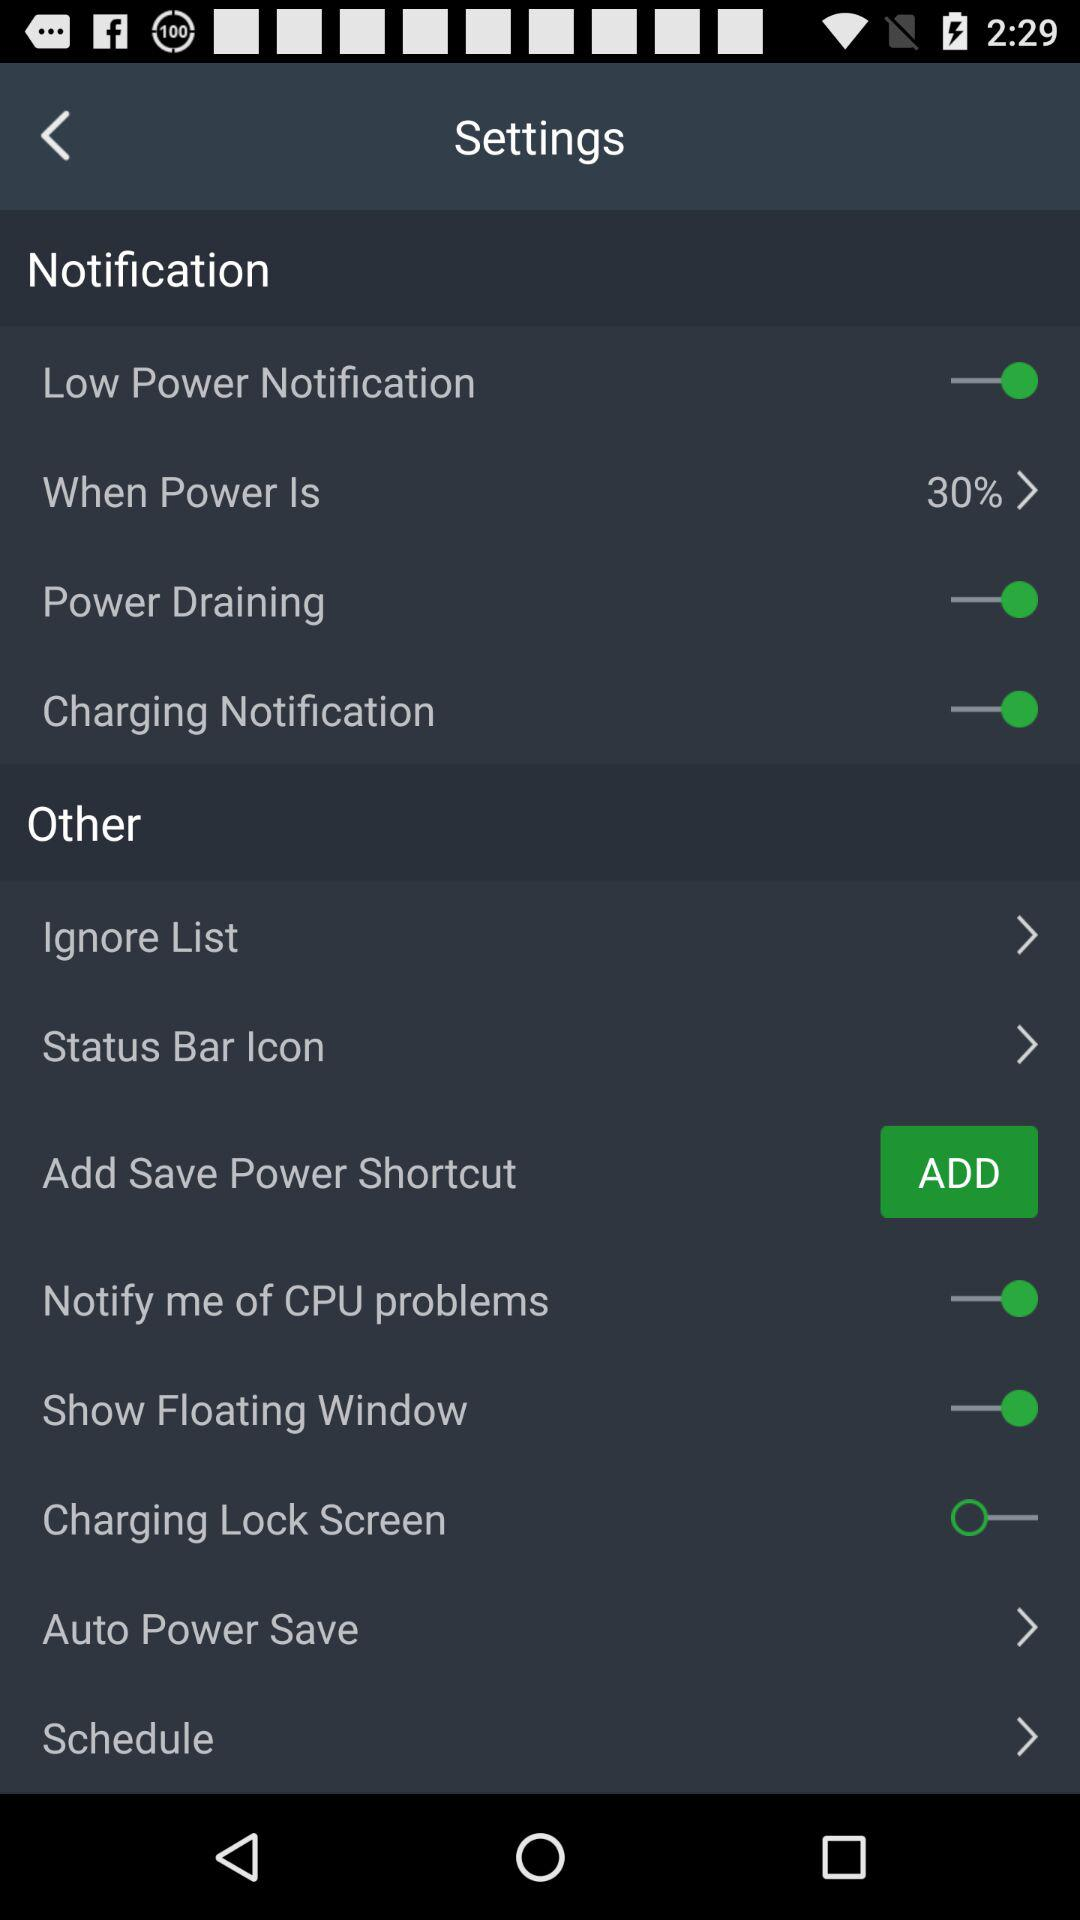How many items have a switch?
Answer the question using a single word or phrase. 6 